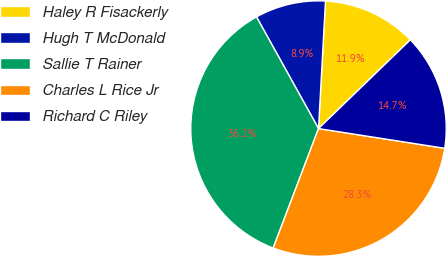Convert chart to OTSL. <chart><loc_0><loc_0><loc_500><loc_500><pie_chart><fcel>Haley R Fisackerly<fcel>Hugh T McDonald<fcel>Sallie T Rainer<fcel>Charles L Rice Jr<fcel>Richard C Riley<nl><fcel>11.9%<fcel>8.94%<fcel>36.16%<fcel>28.31%<fcel>14.7%<nl></chart> 